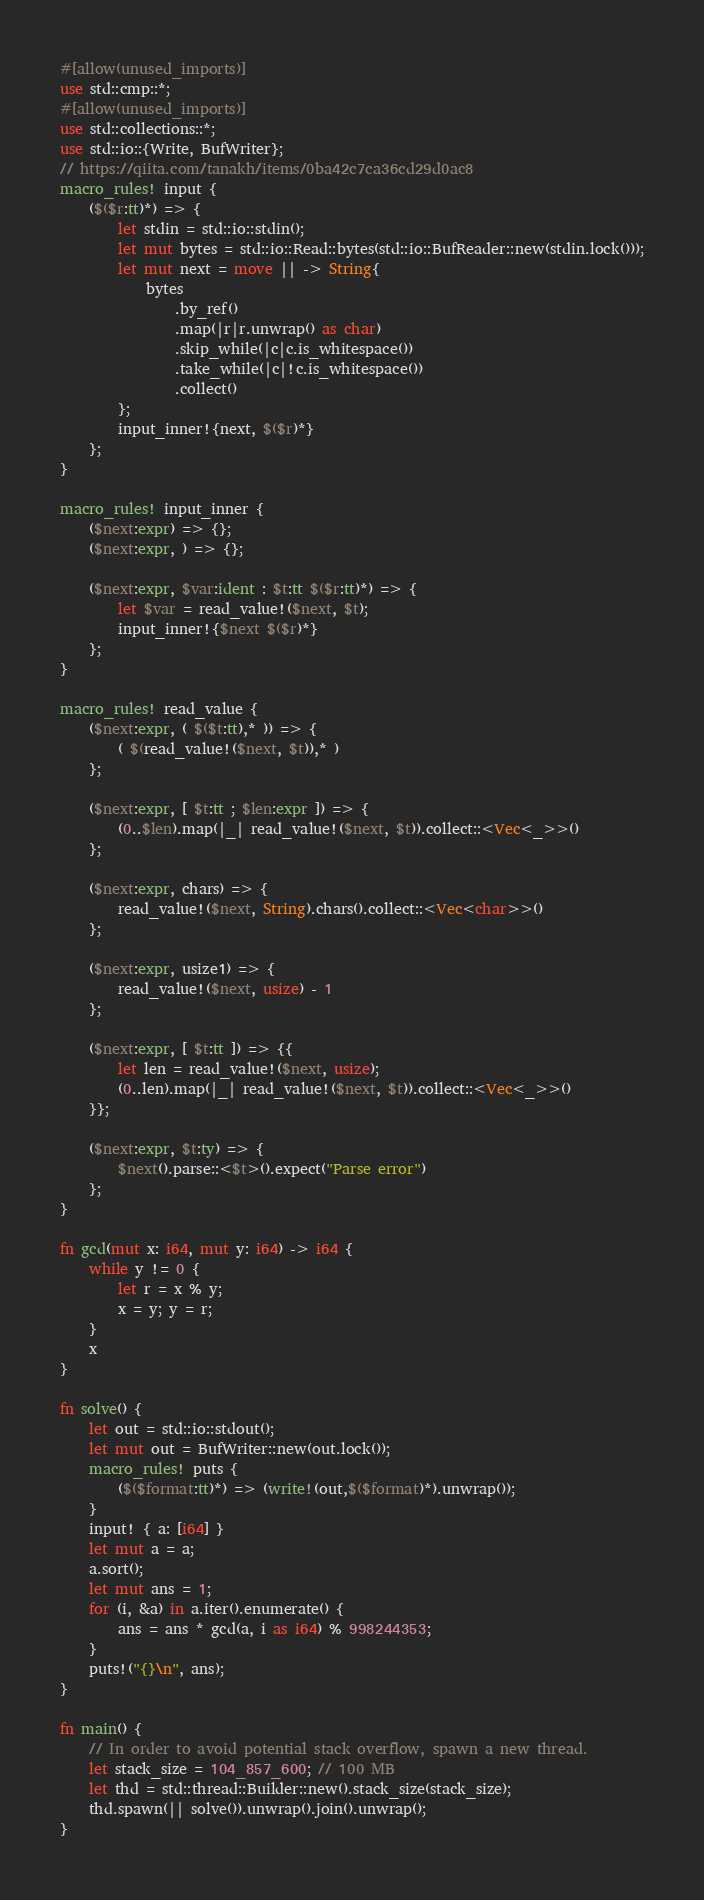<code> <loc_0><loc_0><loc_500><loc_500><_Rust_>#[allow(unused_imports)]
use std::cmp::*;
#[allow(unused_imports)]
use std::collections::*;
use std::io::{Write, BufWriter};
// https://qiita.com/tanakh/items/0ba42c7ca36cd29d0ac8
macro_rules! input {
    ($($r:tt)*) => {
        let stdin = std::io::stdin();
        let mut bytes = std::io::Read::bytes(std::io::BufReader::new(stdin.lock()));
        let mut next = move || -> String{
            bytes
                .by_ref()
                .map(|r|r.unwrap() as char)
                .skip_while(|c|c.is_whitespace())
                .take_while(|c|!c.is_whitespace())
                .collect()
        };
        input_inner!{next, $($r)*}
    };
}

macro_rules! input_inner {
    ($next:expr) => {};
    ($next:expr, ) => {};

    ($next:expr, $var:ident : $t:tt $($r:tt)*) => {
        let $var = read_value!($next, $t);
        input_inner!{$next $($r)*}
    };
}

macro_rules! read_value {
    ($next:expr, ( $($t:tt),* )) => {
        ( $(read_value!($next, $t)),* )
    };

    ($next:expr, [ $t:tt ; $len:expr ]) => {
        (0..$len).map(|_| read_value!($next, $t)).collect::<Vec<_>>()
    };

    ($next:expr, chars) => {
        read_value!($next, String).chars().collect::<Vec<char>>()
    };

    ($next:expr, usize1) => {
        read_value!($next, usize) - 1
    };

    ($next:expr, [ $t:tt ]) => {{
        let len = read_value!($next, usize);
        (0..len).map(|_| read_value!($next, $t)).collect::<Vec<_>>()
    }};

    ($next:expr, $t:ty) => {
        $next().parse::<$t>().expect("Parse error")
    };
}

fn gcd(mut x: i64, mut y: i64) -> i64 {
    while y != 0 {
        let r = x % y;
        x = y; y = r;
    }
    x
}

fn solve() {
    let out = std::io::stdout();
    let mut out = BufWriter::new(out.lock());
    macro_rules! puts {
        ($($format:tt)*) => (write!(out,$($format)*).unwrap());
    }
    input! { a: [i64] }
    let mut a = a;
    a.sort();
    let mut ans = 1;
    for (i, &a) in a.iter().enumerate() {
        ans = ans * gcd(a, i as i64) % 998244353;
    }
    puts!("{}\n", ans);
}

fn main() {
    // In order to avoid potential stack overflow, spawn a new thread.
    let stack_size = 104_857_600; // 100 MB
    let thd = std::thread::Builder::new().stack_size(stack_size);
    thd.spawn(|| solve()).unwrap().join().unwrap();
}
</code> 